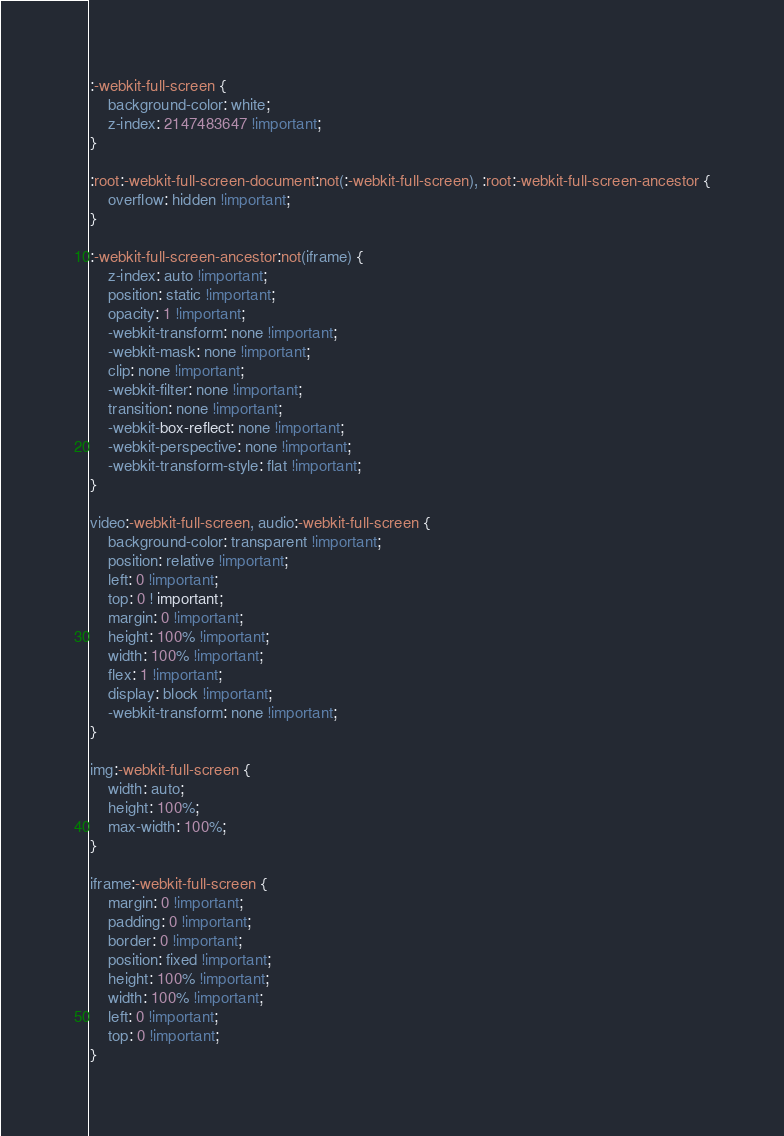<code> <loc_0><loc_0><loc_500><loc_500><_CSS_>:-webkit-full-screen {
    background-color: white;
    z-index: 2147483647 !important;
}

:root:-webkit-full-screen-document:not(:-webkit-full-screen), :root:-webkit-full-screen-ancestor {
    overflow: hidden !important;
}

:-webkit-full-screen-ancestor:not(iframe) {
    z-index: auto !important;
    position: static !important;
    opacity: 1 !important;
    -webkit-transform: none !important;
    -webkit-mask: none !important;
    clip: none !important;
    -webkit-filter: none !important;
    transition: none !important;
    -webkit-box-reflect: none !important;
    -webkit-perspective: none !important;
    -webkit-transform-style: flat !important;
}

video:-webkit-full-screen, audio:-webkit-full-screen {
    background-color: transparent !important;
    position: relative !important;
    left: 0 !important;
    top: 0 ! important;
    margin: 0 !important;
    height: 100% !important;
    width: 100% !important;
    flex: 1 !important;
    display: block !important;
    -webkit-transform: none !important;
}

img:-webkit-full-screen {
    width: auto;
    height: 100%;
    max-width: 100%;
}

iframe:-webkit-full-screen {
    margin: 0 !important;
    padding: 0 !important;
    border: 0 !important;
    position: fixed !important;
    height: 100% !important;
    width: 100% !important;
    left: 0 !important;
    top: 0 !important;
}
</code> 